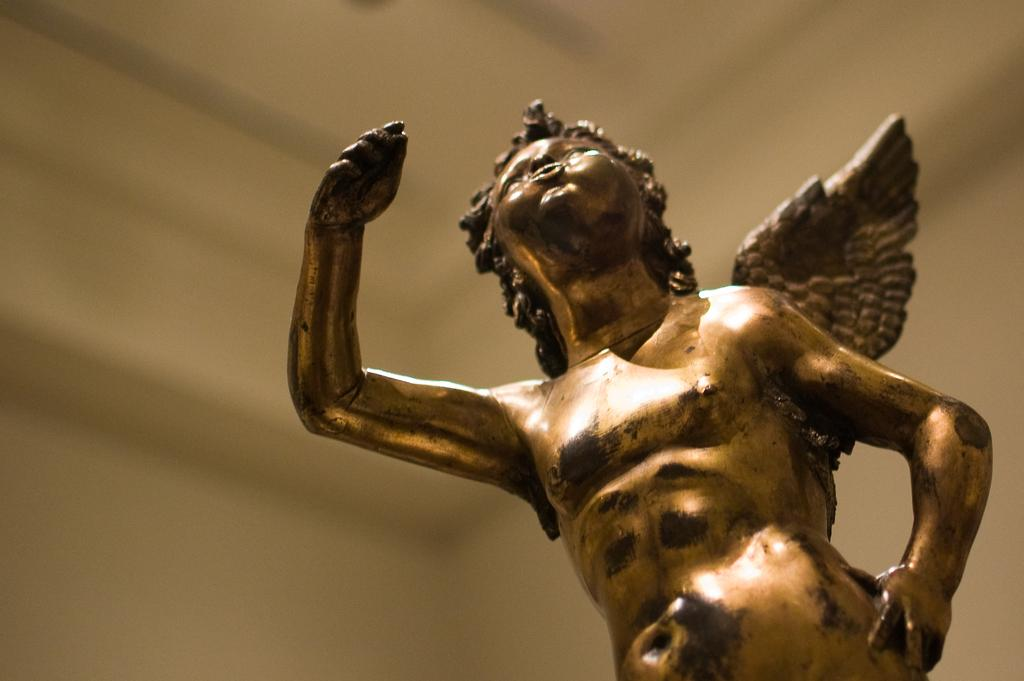Where was the image most likely taken? The image was likely taken indoors. What is the main subject of the image? There is a sculpture of a person with wings in the image. On which side of the image is the sculpture located? The sculpture is on the right side of the image. What can be seen in the background of the image? There is a wall and a roof visible in the background of the image. What type of pickle is being used as a knee support in the image? There is no pickle or knee support present in the image; it features a sculpture of a person with wings. What invention is being showcased in the image? The image does not showcase any specific invention; it features a sculpture of a person with wings. 